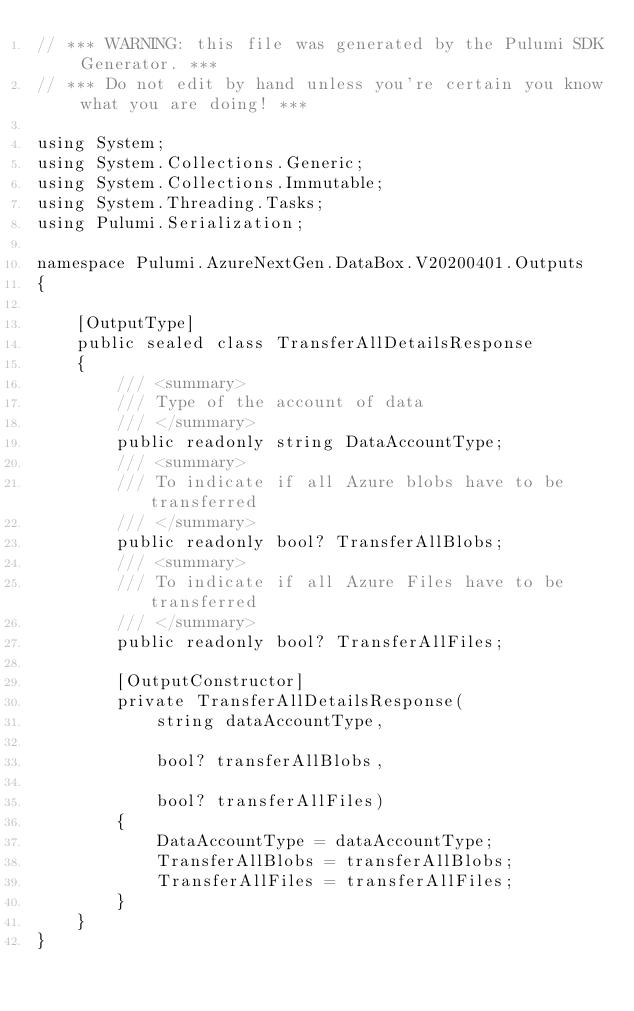<code> <loc_0><loc_0><loc_500><loc_500><_C#_>// *** WARNING: this file was generated by the Pulumi SDK Generator. ***
// *** Do not edit by hand unless you're certain you know what you are doing! ***

using System;
using System.Collections.Generic;
using System.Collections.Immutable;
using System.Threading.Tasks;
using Pulumi.Serialization;

namespace Pulumi.AzureNextGen.DataBox.V20200401.Outputs
{

    [OutputType]
    public sealed class TransferAllDetailsResponse
    {
        /// <summary>
        /// Type of the account of data
        /// </summary>
        public readonly string DataAccountType;
        /// <summary>
        /// To indicate if all Azure blobs have to be transferred
        /// </summary>
        public readonly bool? TransferAllBlobs;
        /// <summary>
        /// To indicate if all Azure Files have to be transferred
        /// </summary>
        public readonly bool? TransferAllFiles;

        [OutputConstructor]
        private TransferAllDetailsResponse(
            string dataAccountType,

            bool? transferAllBlobs,

            bool? transferAllFiles)
        {
            DataAccountType = dataAccountType;
            TransferAllBlobs = transferAllBlobs;
            TransferAllFiles = transferAllFiles;
        }
    }
}
</code> 